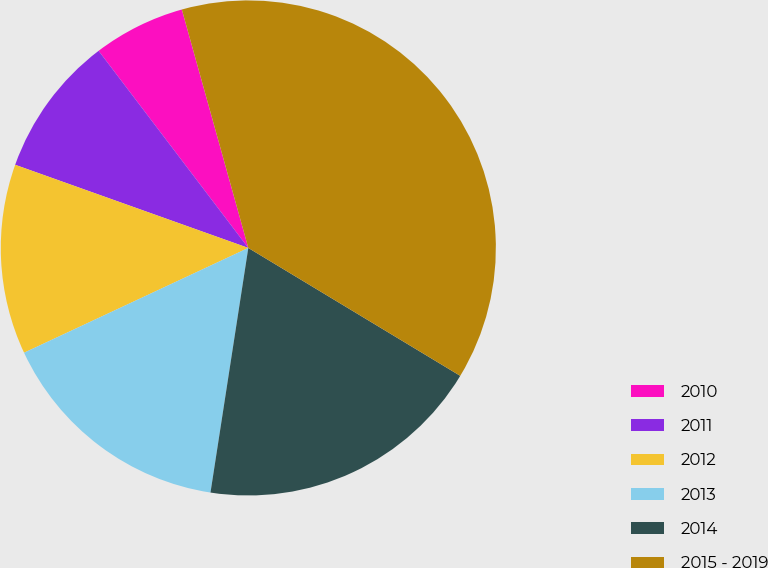<chart> <loc_0><loc_0><loc_500><loc_500><pie_chart><fcel>2010<fcel>2011<fcel>2012<fcel>2013<fcel>2014<fcel>2015 - 2019<nl><fcel>6.01%<fcel>9.21%<fcel>12.41%<fcel>15.6%<fcel>18.8%<fcel>37.97%<nl></chart> 